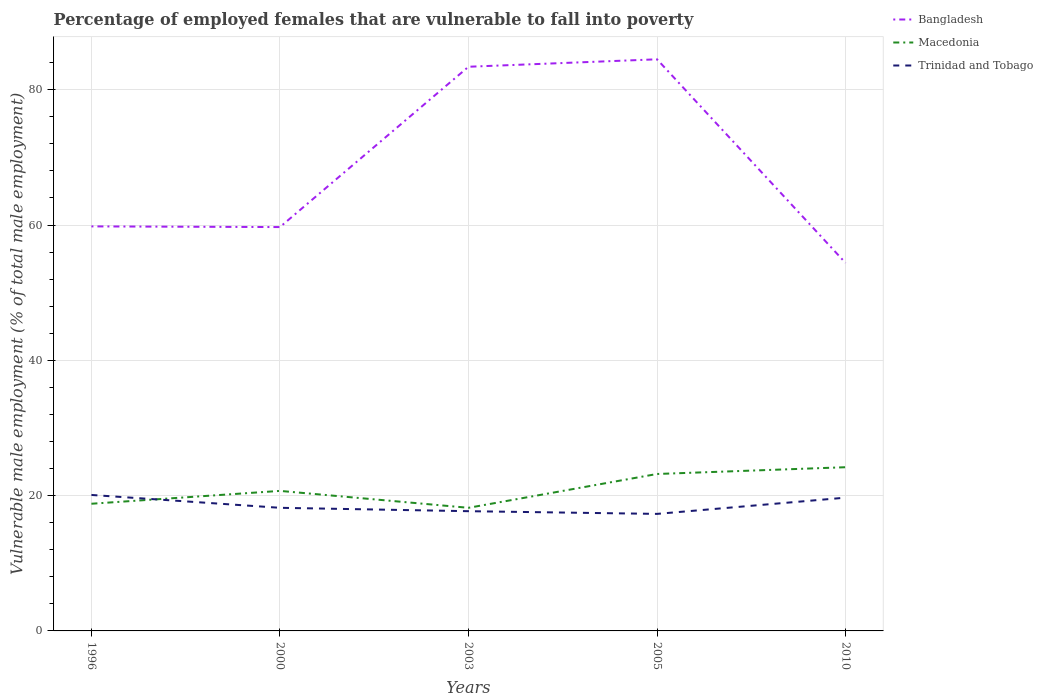Is the number of lines equal to the number of legend labels?
Provide a succinct answer. Yes. Across all years, what is the maximum percentage of employed females who are vulnerable to fall into poverty in Macedonia?
Your answer should be very brief. 18.2. What is the total percentage of employed females who are vulnerable to fall into poverty in Bangladesh in the graph?
Ensure brevity in your answer.  29. What is the difference between the highest and the second highest percentage of employed females who are vulnerable to fall into poverty in Trinidad and Tobago?
Your response must be concise. 2.8. How many lines are there?
Provide a short and direct response. 3. How many years are there in the graph?
Your answer should be very brief. 5. What is the difference between two consecutive major ticks on the Y-axis?
Your answer should be very brief. 20. Does the graph contain grids?
Keep it short and to the point. Yes. Where does the legend appear in the graph?
Your response must be concise. Top right. What is the title of the graph?
Make the answer very short. Percentage of employed females that are vulnerable to fall into poverty. Does "Croatia" appear as one of the legend labels in the graph?
Ensure brevity in your answer.  No. What is the label or title of the X-axis?
Keep it short and to the point. Years. What is the label or title of the Y-axis?
Offer a terse response. Vulnerable male employment (% of total male employment). What is the Vulnerable male employment (% of total male employment) of Bangladesh in 1996?
Provide a short and direct response. 59.8. What is the Vulnerable male employment (% of total male employment) in Macedonia in 1996?
Make the answer very short. 18.8. What is the Vulnerable male employment (% of total male employment) of Trinidad and Tobago in 1996?
Offer a terse response. 20.1. What is the Vulnerable male employment (% of total male employment) in Bangladesh in 2000?
Offer a very short reply. 59.7. What is the Vulnerable male employment (% of total male employment) of Macedonia in 2000?
Offer a very short reply. 20.7. What is the Vulnerable male employment (% of total male employment) of Trinidad and Tobago in 2000?
Keep it short and to the point. 18.2. What is the Vulnerable male employment (% of total male employment) in Bangladesh in 2003?
Keep it short and to the point. 83.4. What is the Vulnerable male employment (% of total male employment) in Macedonia in 2003?
Provide a short and direct response. 18.2. What is the Vulnerable male employment (% of total male employment) of Trinidad and Tobago in 2003?
Provide a short and direct response. 17.7. What is the Vulnerable male employment (% of total male employment) of Bangladesh in 2005?
Your answer should be compact. 84.5. What is the Vulnerable male employment (% of total male employment) of Macedonia in 2005?
Your response must be concise. 23.2. What is the Vulnerable male employment (% of total male employment) of Trinidad and Tobago in 2005?
Offer a terse response. 17.3. What is the Vulnerable male employment (% of total male employment) in Bangladesh in 2010?
Your answer should be compact. 54.4. What is the Vulnerable male employment (% of total male employment) of Macedonia in 2010?
Ensure brevity in your answer.  24.2. What is the Vulnerable male employment (% of total male employment) of Trinidad and Tobago in 2010?
Your response must be concise. 19.7. Across all years, what is the maximum Vulnerable male employment (% of total male employment) of Bangladesh?
Your response must be concise. 84.5. Across all years, what is the maximum Vulnerable male employment (% of total male employment) in Macedonia?
Ensure brevity in your answer.  24.2. Across all years, what is the maximum Vulnerable male employment (% of total male employment) in Trinidad and Tobago?
Provide a short and direct response. 20.1. Across all years, what is the minimum Vulnerable male employment (% of total male employment) in Bangladesh?
Give a very brief answer. 54.4. Across all years, what is the minimum Vulnerable male employment (% of total male employment) of Macedonia?
Provide a succinct answer. 18.2. Across all years, what is the minimum Vulnerable male employment (% of total male employment) of Trinidad and Tobago?
Offer a terse response. 17.3. What is the total Vulnerable male employment (% of total male employment) in Bangladesh in the graph?
Ensure brevity in your answer.  341.8. What is the total Vulnerable male employment (% of total male employment) in Macedonia in the graph?
Offer a terse response. 105.1. What is the total Vulnerable male employment (% of total male employment) in Trinidad and Tobago in the graph?
Your answer should be compact. 93. What is the difference between the Vulnerable male employment (% of total male employment) in Bangladesh in 1996 and that in 2000?
Give a very brief answer. 0.1. What is the difference between the Vulnerable male employment (% of total male employment) in Macedonia in 1996 and that in 2000?
Ensure brevity in your answer.  -1.9. What is the difference between the Vulnerable male employment (% of total male employment) of Trinidad and Tobago in 1996 and that in 2000?
Offer a terse response. 1.9. What is the difference between the Vulnerable male employment (% of total male employment) of Bangladesh in 1996 and that in 2003?
Your answer should be very brief. -23.6. What is the difference between the Vulnerable male employment (% of total male employment) in Bangladesh in 1996 and that in 2005?
Your answer should be compact. -24.7. What is the difference between the Vulnerable male employment (% of total male employment) in Macedonia in 1996 and that in 2005?
Keep it short and to the point. -4.4. What is the difference between the Vulnerable male employment (% of total male employment) in Trinidad and Tobago in 1996 and that in 2005?
Make the answer very short. 2.8. What is the difference between the Vulnerable male employment (% of total male employment) of Macedonia in 1996 and that in 2010?
Your answer should be compact. -5.4. What is the difference between the Vulnerable male employment (% of total male employment) of Bangladesh in 2000 and that in 2003?
Provide a short and direct response. -23.7. What is the difference between the Vulnerable male employment (% of total male employment) of Trinidad and Tobago in 2000 and that in 2003?
Your answer should be compact. 0.5. What is the difference between the Vulnerable male employment (% of total male employment) in Bangladesh in 2000 and that in 2005?
Offer a very short reply. -24.8. What is the difference between the Vulnerable male employment (% of total male employment) of Trinidad and Tobago in 2000 and that in 2005?
Your answer should be compact. 0.9. What is the difference between the Vulnerable male employment (% of total male employment) in Bangladesh in 2003 and that in 2005?
Offer a very short reply. -1.1. What is the difference between the Vulnerable male employment (% of total male employment) in Bangladesh in 2003 and that in 2010?
Provide a succinct answer. 29. What is the difference between the Vulnerable male employment (% of total male employment) of Bangladesh in 2005 and that in 2010?
Your answer should be very brief. 30.1. What is the difference between the Vulnerable male employment (% of total male employment) in Trinidad and Tobago in 2005 and that in 2010?
Provide a short and direct response. -2.4. What is the difference between the Vulnerable male employment (% of total male employment) in Bangladesh in 1996 and the Vulnerable male employment (% of total male employment) in Macedonia in 2000?
Keep it short and to the point. 39.1. What is the difference between the Vulnerable male employment (% of total male employment) of Bangladesh in 1996 and the Vulnerable male employment (% of total male employment) of Trinidad and Tobago in 2000?
Your answer should be very brief. 41.6. What is the difference between the Vulnerable male employment (% of total male employment) in Macedonia in 1996 and the Vulnerable male employment (% of total male employment) in Trinidad and Tobago in 2000?
Give a very brief answer. 0.6. What is the difference between the Vulnerable male employment (% of total male employment) of Bangladesh in 1996 and the Vulnerable male employment (% of total male employment) of Macedonia in 2003?
Ensure brevity in your answer.  41.6. What is the difference between the Vulnerable male employment (% of total male employment) of Bangladesh in 1996 and the Vulnerable male employment (% of total male employment) of Trinidad and Tobago in 2003?
Provide a succinct answer. 42.1. What is the difference between the Vulnerable male employment (% of total male employment) in Bangladesh in 1996 and the Vulnerable male employment (% of total male employment) in Macedonia in 2005?
Your answer should be very brief. 36.6. What is the difference between the Vulnerable male employment (% of total male employment) in Bangladesh in 1996 and the Vulnerable male employment (% of total male employment) in Trinidad and Tobago in 2005?
Make the answer very short. 42.5. What is the difference between the Vulnerable male employment (% of total male employment) in Bangladesh in 1996 and the Vulnerable male employment (% of total male employment) in Macedonia in 2010?
Provide a short and direct response. 35.6. What is the difference between the Vulnerable male employment (% of total male employment) in Bangladesh in 1996 and the Vulnerable male employment (% of total male employment) in Trinidad and Tobago in 2010?
Ensure brevity in your answer.  40.1. What is the difference between the Vulnerable male employment (% of total male employment) of Bangladesh in 2000 and the Vulnerable male employment (% of total male employment) of Macedonia in 2003?
Provide a succinct answer. 41.5. What is the difference between the Vulnerable male employment (% of total male employment) in Bangladesh in 2000 and the Vulnerable male employment (% of total male employment) in Macedonia in 2005?
Your response must be concise. 36.5. What is the difference between the Vulnerable male employment (% of total male employment) in Bangladesh in 2000 and the Vulnerable male employment (% of total male employment) in Trinidad and Tobago in 2005?
Give a very brief answer. 42.4. What is the difference between the Vulnerable male employment (% of total male employment) in Macedonia in 2000 and the Vulnerable male employment (% of total male employment) in Trinidad and Tobago in 2005?
Give a very brief answer. 3.4. What is the difference between the Vulnerable male employment (% of total male employment) in Bangladesh in 2000 and the Vulnerable male employment (% of total male employment) in Macedonia in 2010?
Make the answer very short. 35.5. What is the difference between the Vulnerable male employment (% of total male employment) in Bangladesh in 2000 and the Vulnerable male employment (% of total male employment) in Trinidad and Tobago in 2010?
Offer a terse response. 40. What is the difference between the Vulnerable male employment (% of total male employment) in Bangladesh in 2003 and the Vulnerable male employment (% of total male employment) in Macedonia in 2005?
Provide a short and direct response. 60.2. What is the difference between the Vulnerable male employment (% of total male employment) in Bangladesh in 2003 and the Vulnerable male employment (% of total male employment) in Trinidad and Tobago in 2005?
Make the answer very short. 66.1. What is the difference between the Vulnerable male employment (% of total male employment) of Bangladesh in 2003 and the Vulnerable male employment (% of total male employment) of Macedonia in 2010?
Give a very brief answer. 59.2. What is the difference between the Vulnerable male employment (% of total male employment) of Bangladesh in 2003 and the Vulnerable male employment (% of total male employment) of Trinidad and Tobago in 2010?
Make the answer very short. 63.7. What is the difference between the Vulnerable male employment (% of total male employment) in Macedonia in 2003 and the Vulnerable male employment (% of total male employment) in Trinidad and Tobago in 2010?
Provide a short and direct response. -1.5. What is the difference between the Vulnerable male employment (% of total male employment) in Bangladesh in 2005 and the Vulnerable male employment (% of total male employment) in Macedonia in 2010?
Your answer should be very brief. 60.3. What is the difference between the Vulnerable male employment (% of total male employment) in Bangladesh in 2005 and the Vulnerable male employment (% of total male employment) in Trinidad and Tobago in 2010?
Provide a short and direct response. 64.8. What is the average Vulnerable male employment (% of total male employment) in Bangladesh per year?
Your answer should be compact. 68.36. What is the average Vulnerable male employment (% of total male employment) of Macedonia per year?
Give a very brief answer. 21.02. In the year 1996, what is the difference between the Vulnerable male employment (% of total male employment) in Bangladesh and Vulnerable male employment (% of total male employment) in Macedonia?
Your response must be concise. 41. In the year 1996, what is the difference between the Vulnerable male employment (% of total male employment) in Bangladesh and Vulnerable male employment (% of total male employment) in Trinidad and Tobago?
Keep it short and to the point. 39.7. In the year 2000, what is the difference between the Vulnerable male employment (% of total male employment) in Bangladesh and Vulnerable male employment (% of total male employment) in Macedonia?
Offer a terse response. 39. In the year 2000, what is the difference between the Vulnerable male employment (% of total male employment) of Bangladesh and Vulnerable male employment (% of total male employment) of Trinidad and Tobago?
Ensure brevity in your answer.  41.5. In the year 2003, what is the difference between the Vulnerable male employment (% of total male employment) in Bangladesh and Vulnerable male employment (% of total male employment) in Macedonia?
Provide a short and direct response. 65.2. In the year 2003, what is the difference between the Vulnerable male employment (% of total male employment) of Bangladesh and Vulnerable male employment (% of total male employment) of Trinidad and Tobago?
Give a very brief answer. 65.7. In the year 2005, what is the difference between the Vulnerable male employment (% of total male employment) in Bangladesh and Vulnerable male employment (% of total male employment) in Macedonia?
Ensure brevity in your answer.  61.3. In the year 2005, what is the difference between the Vulnerable male employment (% of total male employment) of Bangladesh and Vulnerable male employment (% of total male employment) of Trinidad and Tobago?
Keep it short and to the point. 67.2. In the year 2010, what is the difference between the Vulnerable male employment (% of total male employment) in Bangladesh and Vulnerable male employment (% of total male employment) in Macedonia?
Provide a short and direct response. 30.2. In the year 2010, what is the difference between the Vulnerable male employment (% of total male employment) of Bangladesh and Vulnerable male employment (% of total male employment) of Trinidad and Tobago?
Ensure brevity in your answer.  34.7. In the year 2010, what is the difference between the Vulnerable male employment (% of total male employment) of Macedonia and Vulnerable male employment (% of total male employment) of Trinidad and Tobago?
Your answer should be compact. 4.5. What is the ratio of the Vulnerable male employment (% of total male employment) in Macedonia in 1996 to that in 2000?
Your answer should be compact. 0.91. What is the ratio of the Vulnerable male employment (% of total male employment) in Trinidad and Tobago in 1996 to that in 2000?
Keep it short and to the point. 1.1. What is the ratio of the Vulnerable male employment (% of total male employment) in Bangladesh in 1996 to that in 2003?
Make the answer very short. 0.72. What is the ratio of the Vulnerable male employment (% of total male employment) of Macedonia in 1996 to that in 2003?
Your answer should be very brief. 1.03. What is the ratio of the Vulnerable male employment (% of total male employment) in Trinidad and Tobago in 1996 to that in 2003?
Your answer should be compact. 1.14. What is the ratio of the Vulnerable male employment (% of total male employment) in Bangladesh in 1996 to that in 2005?
Provide a succinct answer. 0.71. What is the ratio of the Vulnerable male employment (% of total male employment) of Macedonia in 1996 to that in 2005?
Keep it short and to the point. 0.81. What is the ratio of the Vulnerable male employment (% of total male employment) of Trinidad and Tobago in 1996 to that in 2005?
Make the answer very short. 1.16. What is the ratio of the Vulnerable male employment (% of total male employment) of Bangladesh in 1996 to that in 2010?
Offer a very short reply. 1.1. What is the ratio of the Vulnerable male employment (% of total male employment) of Macedonia in 1996 to that in 2010?
Make the answer very short. 0.78. What is the ratio of the Vulnerable male employment (% of total male employment) of Trinidad and Tobago in 1996 to that in 2010?
Your answer should be very brief. 1.02. What is the ratio of the Vulnerable male employment (% of total male employment) in Bangladesh in 2000 to that in 2003?
Give a very brief answer. 0.72. What is the ratio of the Vulnerable male employment (% of total male employment) in Macedonia in 2000 to that in 2003?
Offer a terse response. 1.14. What is the ratio of the Vulnerable male employment (% of total male employment) in Trinidad and Tobago in 2000 to that in 2003?
Your answer should be compact. 1.03. What is the ratio of the Vulnerable male employment (% of total male employment) in Bangladesh in 2000 to that in 2005?
Keep it short and to the point. 0.71. What is the ratio of the Vulnerable male employment (% of total male employment) of Macedonia in 2000 to that in 2005?
Keep it short and to the point. 0.89. What is the ratio of the Vulnerable male employment (% of total male employment) in Trinidad and Tobago in 2000 to that in 2005?
Give a very brief answer. 1.05. What is the ratio of the Vulnerable male employment (% of total male employment) in Bangladesh in 2000 to that in 2010?
Your answer should be very brief. 1.1. What is the ratio of the Vulnerable male employment (% of total male employment) of Macedonia in 2000 to that in 2010?
Offer a terse response. 0.86. What is the ratio of the Vulnerable male employment (% of total male employment) in Trinidad and Tobago in 2000 to that in 2010?
Give a very brief answer. 0.92. What is the ratio of the Vulnerable male employment (% of total male employment) of Macedonia in 2003 to that in 2005?
Keep it short and to the point. 0.78. What is the ratio of the Vulnerable male employment (% of total male employment) in Trinidad and Tobago in 2003 to that in 2005?
Your answer should be very brief. 1.02. What is the ratio of the Vulnerable male employment (% of total male employment) of Bangladesh in 2003 to that in 2010?
Your answer should be very brief. 1.53. What is the ratio of the Vulnerable male employment (% of total male employment) in Macedonia in 2003 to that in 2010?
Offer a terse response. 0.75. What is the ratio of the Vulnerable male employment (% of total male employment) of Trinidad and Tobago in 2003 to that in 2010?
Provide a short and direct response. 0.9. What is the ratio of the Vulnerable male employment (% of total male employment) of Bangladesh in 2005 to that in 2010?
Keep it short and to the point. 1.55. What is the ratio of the Vulnerable male employment (% of total male employment) of Macedonia in 2005 to that in 2010?
Your response must be concise. 0.96. What is the ratio of the Vulnerable male employment (% of total male employment) of Trinidad and Tobago in 2005 to that in 2010?
Your answer should be very brief. 0.88. What is the difference between the highest and the second highest Vulnerable male employment (% of total male employment) of Bangladesh?
Keep it short and to the point. 1.1. What is the difference between the highest and the second highest Vulnerable male employment (% of total male employment) of Trinidad and Tobago?
Give a very brief answer. 0.4. What is the difference between the highest and the lowest Vulnerable male employment (% of total male employment) of Bangladesh?
Provide a succinct answer. 30.1. What is the difference between the highest and the lowest Vulnerable male employment (% of total male employment) of Trinidad and Tobago?
Your answer should be compact. 2.8. 